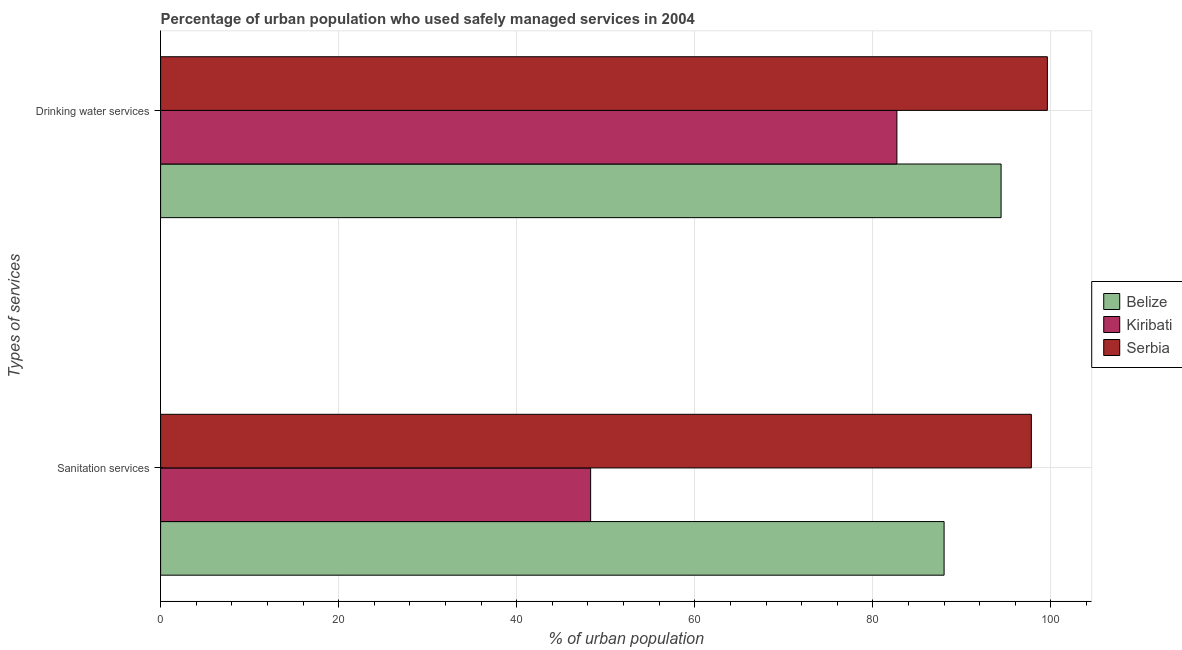Are the number of bars per tick equal to the number of legend labels?
Provide a succinct answer. Yes. What is the label of the 1st group of bars from the top?
Provide a succinct answer. Drinking water services. What is the percentage of urban population who used sanitation services in Kiribati?
Make the answer very short. 48.3. Across all countries, what is the maximum percentage of urban population who used sanitation services?
Offer a terse response. 97.8. Across all countries, what is the minimum percentage of urban population who used drinking water services?
Offer a terse response. 82.7. In which country was the percentage of urban population who used drinking water services maximum?
Offer a terse response. Serbia. In which country was the percentage of urban population who used drinking water services minimum?
Ensure brevity in your answer.  Kiribati. What is the total percentage of urban population who used sanitation services in the graph?
Your answer should be very brief. 234.1. What is the difference between the percentage of urban population who used drinking water services in Belize and that in Serbia?
Your answer should be very brief. -5.2. What is the difference between the percentage of urban population who used drinking water services in Belize and the percentage of urban population who used sanitation services in Kiribati?
Keep it short and to the point. 46.1. What is the average percentage of urban population who used sanitation services per country?
Offer a very short reply. 78.03. What is the difference between the percentage of urban population who used sanitation services and percentage of urban population who used drinking water services in Serbia?
Offer a very short reply. -1.8. What is the ratio of the percentage of urban population who used sanitation services in Belize to that in Serbia?
Offer a very short reply. 0.9. What does the 2nd bar from the top in Drinking water services represents?
Your answer should be compact. Kiribati. What does the 2nd bar from the bottom in Drinking water services represents?
Your answer should be very brief. Kiribati. How many countries are there in the graph?
Your response must be concise. 3. Are the values on the major ticks of X-axis written in scientific E-notation?
Your response must be concise. No. Does the graph contain any zero values?
Offer a very short reply. No. Where does the legend appear in the graph?
Your answer should be very brief. Center right. What is the title of the graph?
Your answer should be very brief. Percentage of urban population who used safely managed services in 2004. What is the label or title of the X-axis?
Ensure brevity in your answer.  % of urban population. What is the label or title of the Y-axis?
Your answer should be compact. Types of services. What is the % of urban population of Kiribati in Sanitation services?
Provide a succinct answer. 48.3. What is the % of urban population of Serbia in Sanitation services?
Your answer should be very brief. 97.8. What is the % of urban population in Belize in Drinking water services?
Your answer should be compact. 94.4. What is the % of urban population of Kiribati in Drinking water services?
Your response must be concise. 82.7. What is the % of urban population of Serbia in Drinking water services?
Offer a very short reply. 99.6. Across all Types of services, what is the maximum % of urban population of Belize?
Your response must be concise. 94.4. Across all Types of services, what is the maximum % of urban population of Kiribati?
Offer a terse response. 82.7. Across all Types of services, what is the maximum % of urban population in Serbia?
Keep it short and to the point. 99.6. Across all Types of services, what is the minimum % of urban population in Kiribati?
Offer a terse response. 48.3. Across all Types of services, what is the minimum % of urban population in Serbia?
Provide a short and direct response. 97.8. What is the total % of urban population in Belize in the graph?
Give a very brief answer. 182.4. What is the total % of urban population in Kiribati in the graph?
Provide a succinct answer. 131. What is the total % of urban population in Serbia in the graph?
Give a very brief answer. 197.4. What is the difference between the % of urban population of Kiribati in Sanitation services and that in Drinking water services?
Your answer should be compact. -34.4. What is the difference between the % of urban population in Belize in Sanitation services and the % of urban population in Kiribati in Drinking water services?
Your answer should be very brief. 5.3. What is the difference between the % of urban population in Kiribati in Sanitation services and the % of urban population in Serbia in Drinking water services?
Make the answer very short. -51.3. What is the average % of urban population in Belize per Types of services?
Your answer should be very brief. 91.2. What is the average % of urban population in Kiribati per Types of services?
Your answer should be very brief. 65.5. What is the average % of urban population in Serbia per Types of services?
Offer a terse response. 98.7. What is the difference between the % of urban population of Belize and % of urban population of Kiribati in Sanitation services?
Offer a terse response. 39.7. What is the difference between the % of urban population of Belize and % of urban population of Serbia in Sanitation services?
Keep it short and to the point. -9.8. What is the difference between the % of urban population in Kiribati and % of urban population in Serbia in Sanitation services?
Make the answer very short. -49.5. What is the difference between the % of urban population of Kiribati and % of urban population of Serbia in Drinking water services?
Your answer should be compact. -16.9. What is the ratio of the % of urban population of Belize in Sanitation services to that in Drinking water services?
Give a very brief answer. 0.93. What is the ratio of the % of urban population of Kiribati in Sanitation services to that in Drinking water services?
Provide a succinct answer. 0.58. What is the ratio of the % of urban population of Serbia in Sanitation services to that in Drinking water services?
Provide a short and direct response. 0.98. What is the difference between the highest and the second highest % of urban population in Belize?
Ensure brevity in your answer.  6.4. What is the difference between the highest and the second highest % of urban population in Kiribati?
Provide a short and direct response. 34.4. What is the difference between the highest and the lowest % of urban population of Kiribati?
Your response must be concise. 34.4. What is the difference between the highest and the lowest % of urban population in Serbia?
Give a very brief answer. 1.8. 